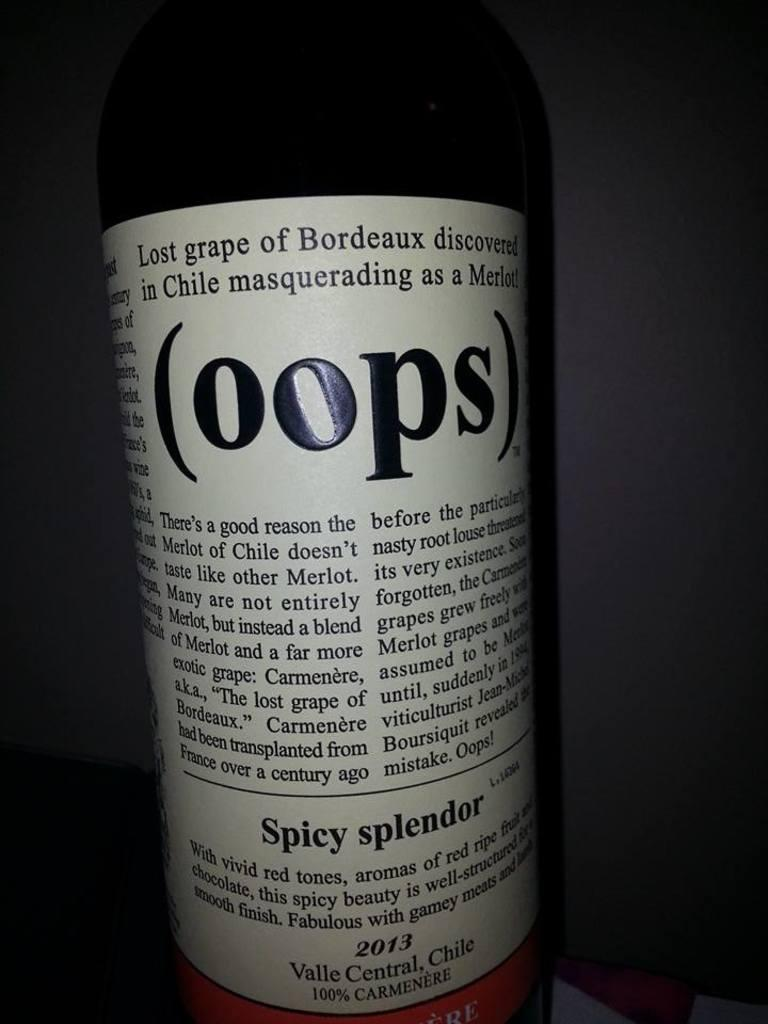<image>
Describe the image concisely. a close up of a wine bottle label reading OOPS 